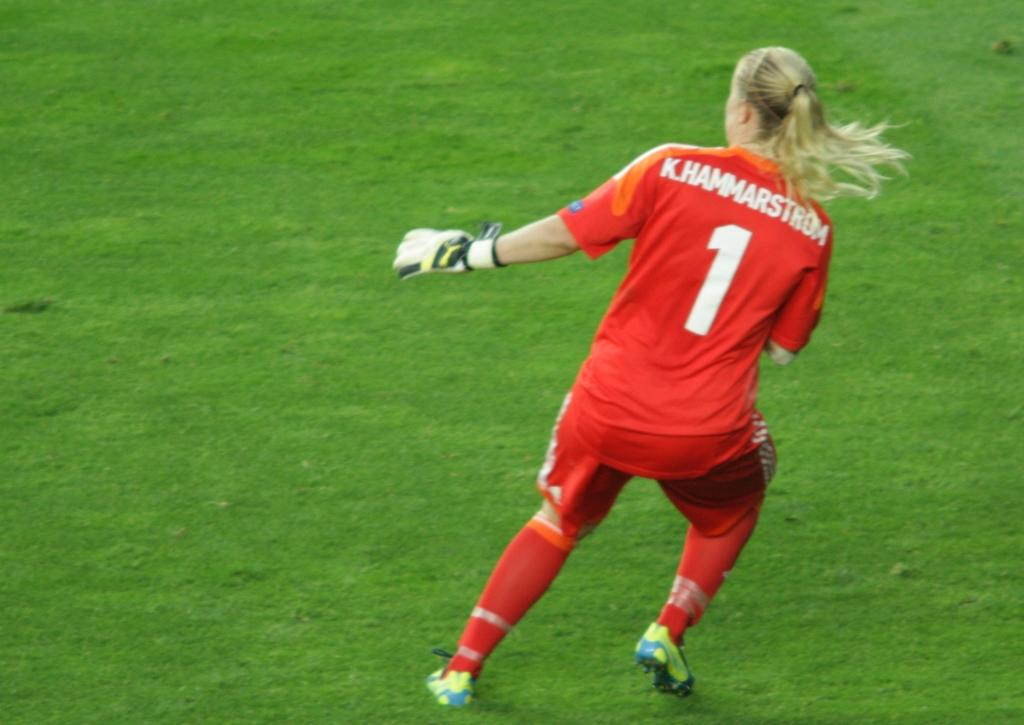<image>
Give a short and clear explanation of the subsequent image. A woman wears a read jersey with K.Hammarstrom on the back. 